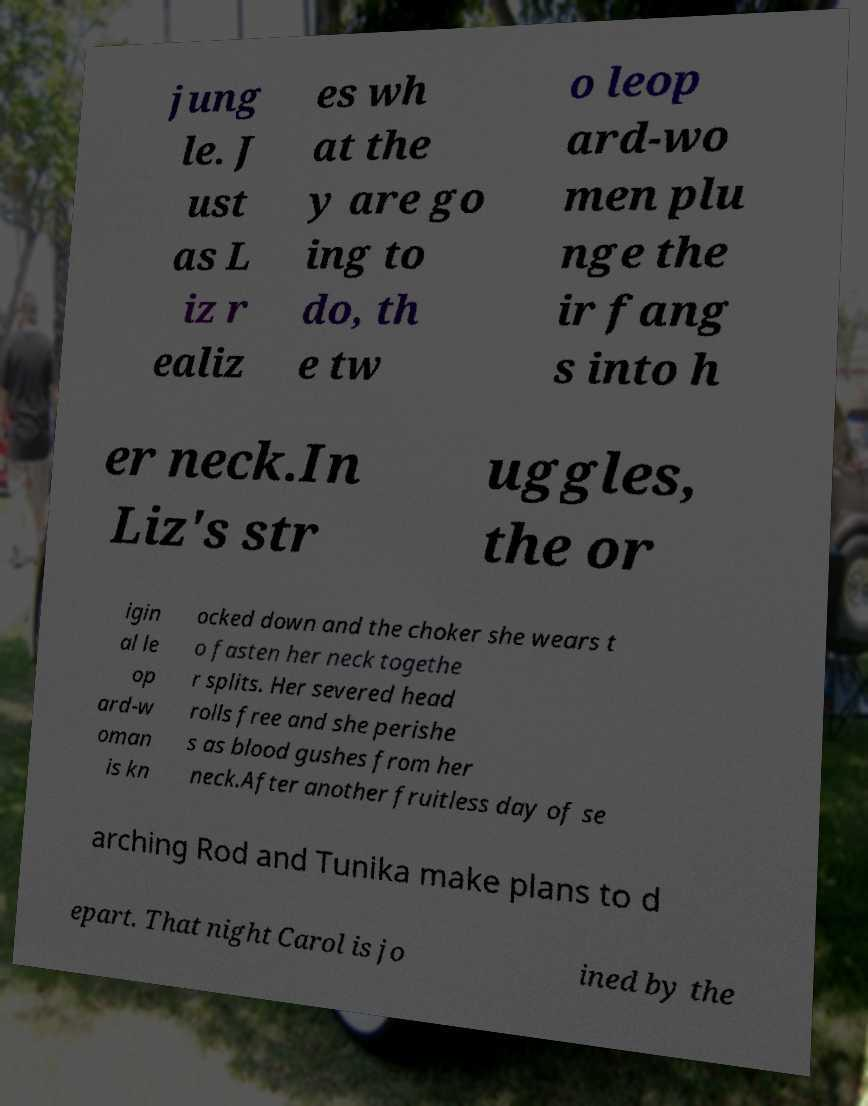What messages or text are displayed in this image? I need them in a readable, typed format. jung le. J ust as L iz r ealiz es wh at the y are go ing to do, th e tw o leop ard-wo men plu nge the ir fang s into h er neck.In Liz's str uggles, the or igin al le op ard-w oman is kn ocked down and the choker she wears t o fasten her neck togethe r splits. Her severed head rolls free and she perishe s as blood gushes from her neck.After another fruitless day of se arching Rod and Tunika make plans to d epart. That night Carol is jo ined by the 